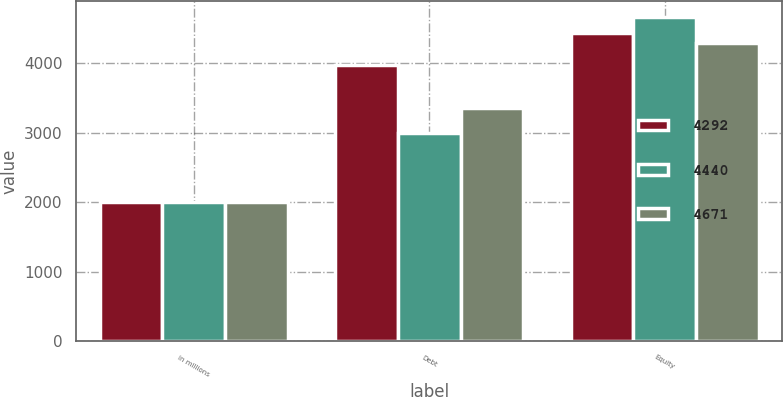Convert chart. <chart><loc_0><loc_0><loc_500><loc_500><stacked_bar_chart><ecel><fcel>in millions<fcel>Debt<fcel>Equity<nl><fcel>4292<fcel>2006<fcel>3979<fcel>4440<nl><fcel>4440<fcel>2005<fcel>2995<fcel>4671<nl><fcel>4671<fcel>2004<fcel>3362<fcel>4292<nl></chart> 